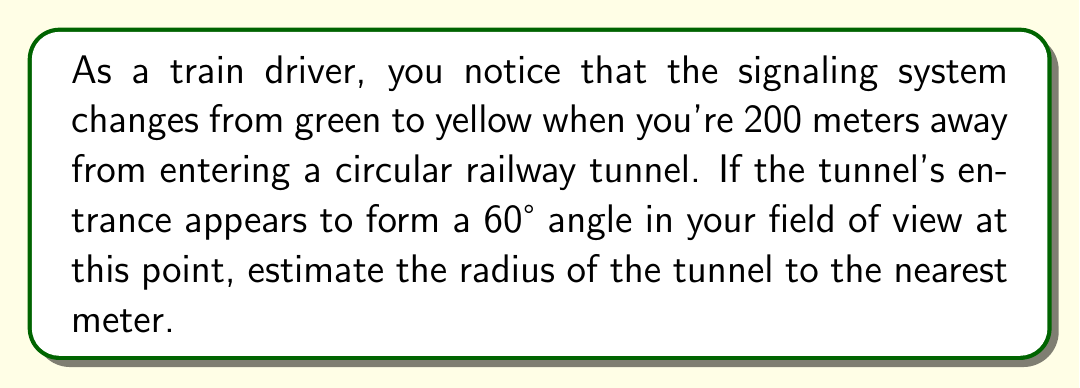Provide a solution to this math problem. Let's approach this step-by-step:

1) First, we need to visualize the problem. The train, the tunnel entrance, and the point where the signal changes form a right-angled triangle.

2) In this triangle:
   - The hypotenuse is the line from the train to the edge of the tunnel
   - The adjacent side is the 200m distance to the tunnel
   - The angle at the train is 30° (half of the 60° angle formed by the tunnel entrance)

3) We can use the tangent function to find the radius:

   $$\tan(30°) = \frac{\text{opposite}}{\text{adjacent}} = \frac{\text{radius}}{200}$$

4) We know that $\tan(30°) = \frac{1}{\sqrt{3}}$, so we can substitute this:

   $$\frac{1}{\sqrt{3}} = \frac{\text{radius}}{200}$$

5) Cross multiply:

   $$200 = \text{radius} \cdot \sqrt{3}$$

6) Solve for radius:

   $$\text{radius} = \frac{200}{\sqrt{3}} \approx 115.47$$

7) Rounding to the nearest meter:

   $$\text{radius} \approx 115 \text{ meters}$$
Answer: 115 meters 